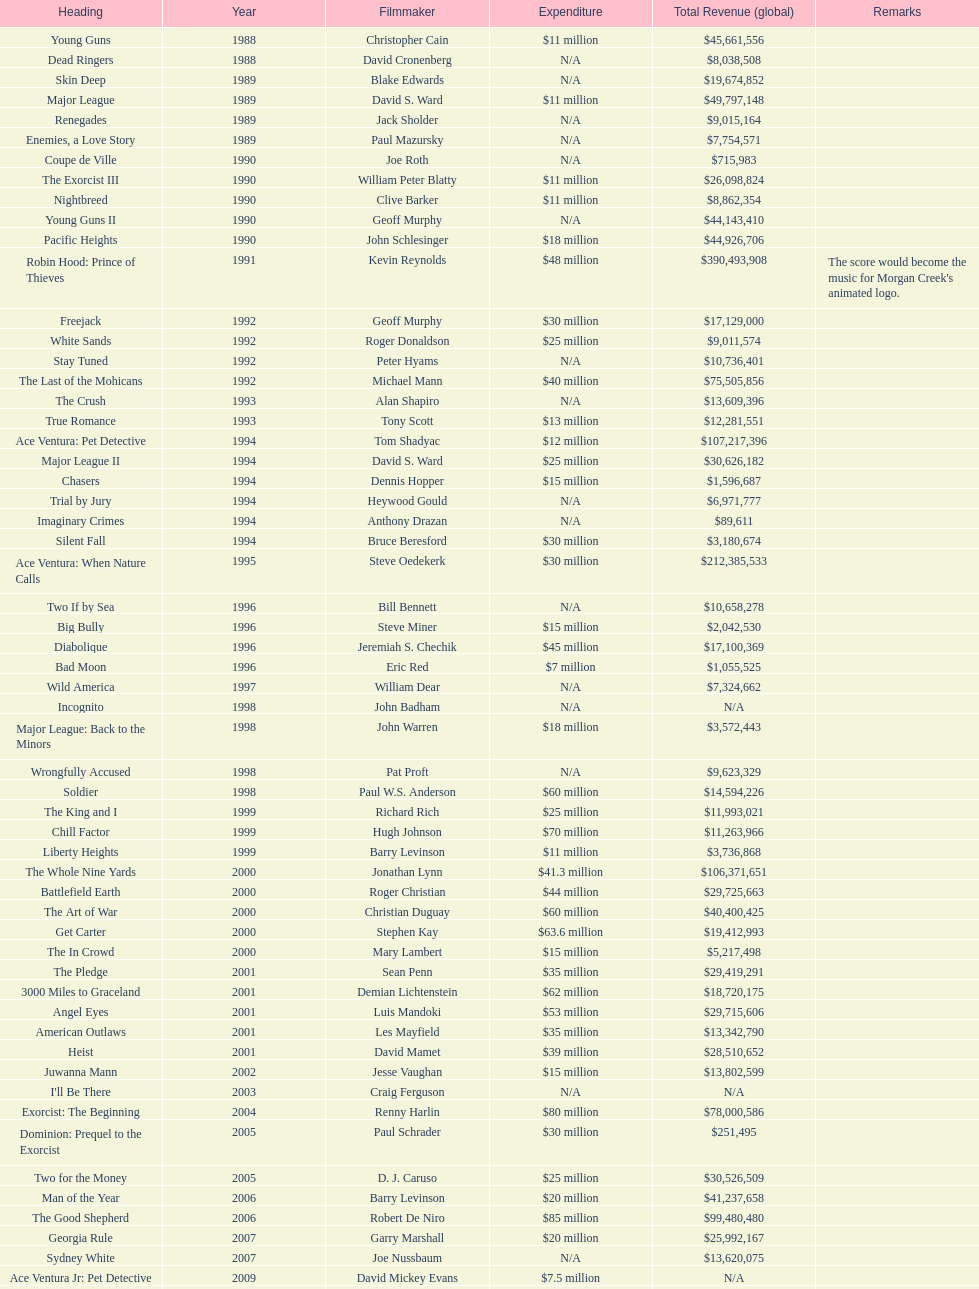What movie was made immediately before the pledge? The In Crowd. 